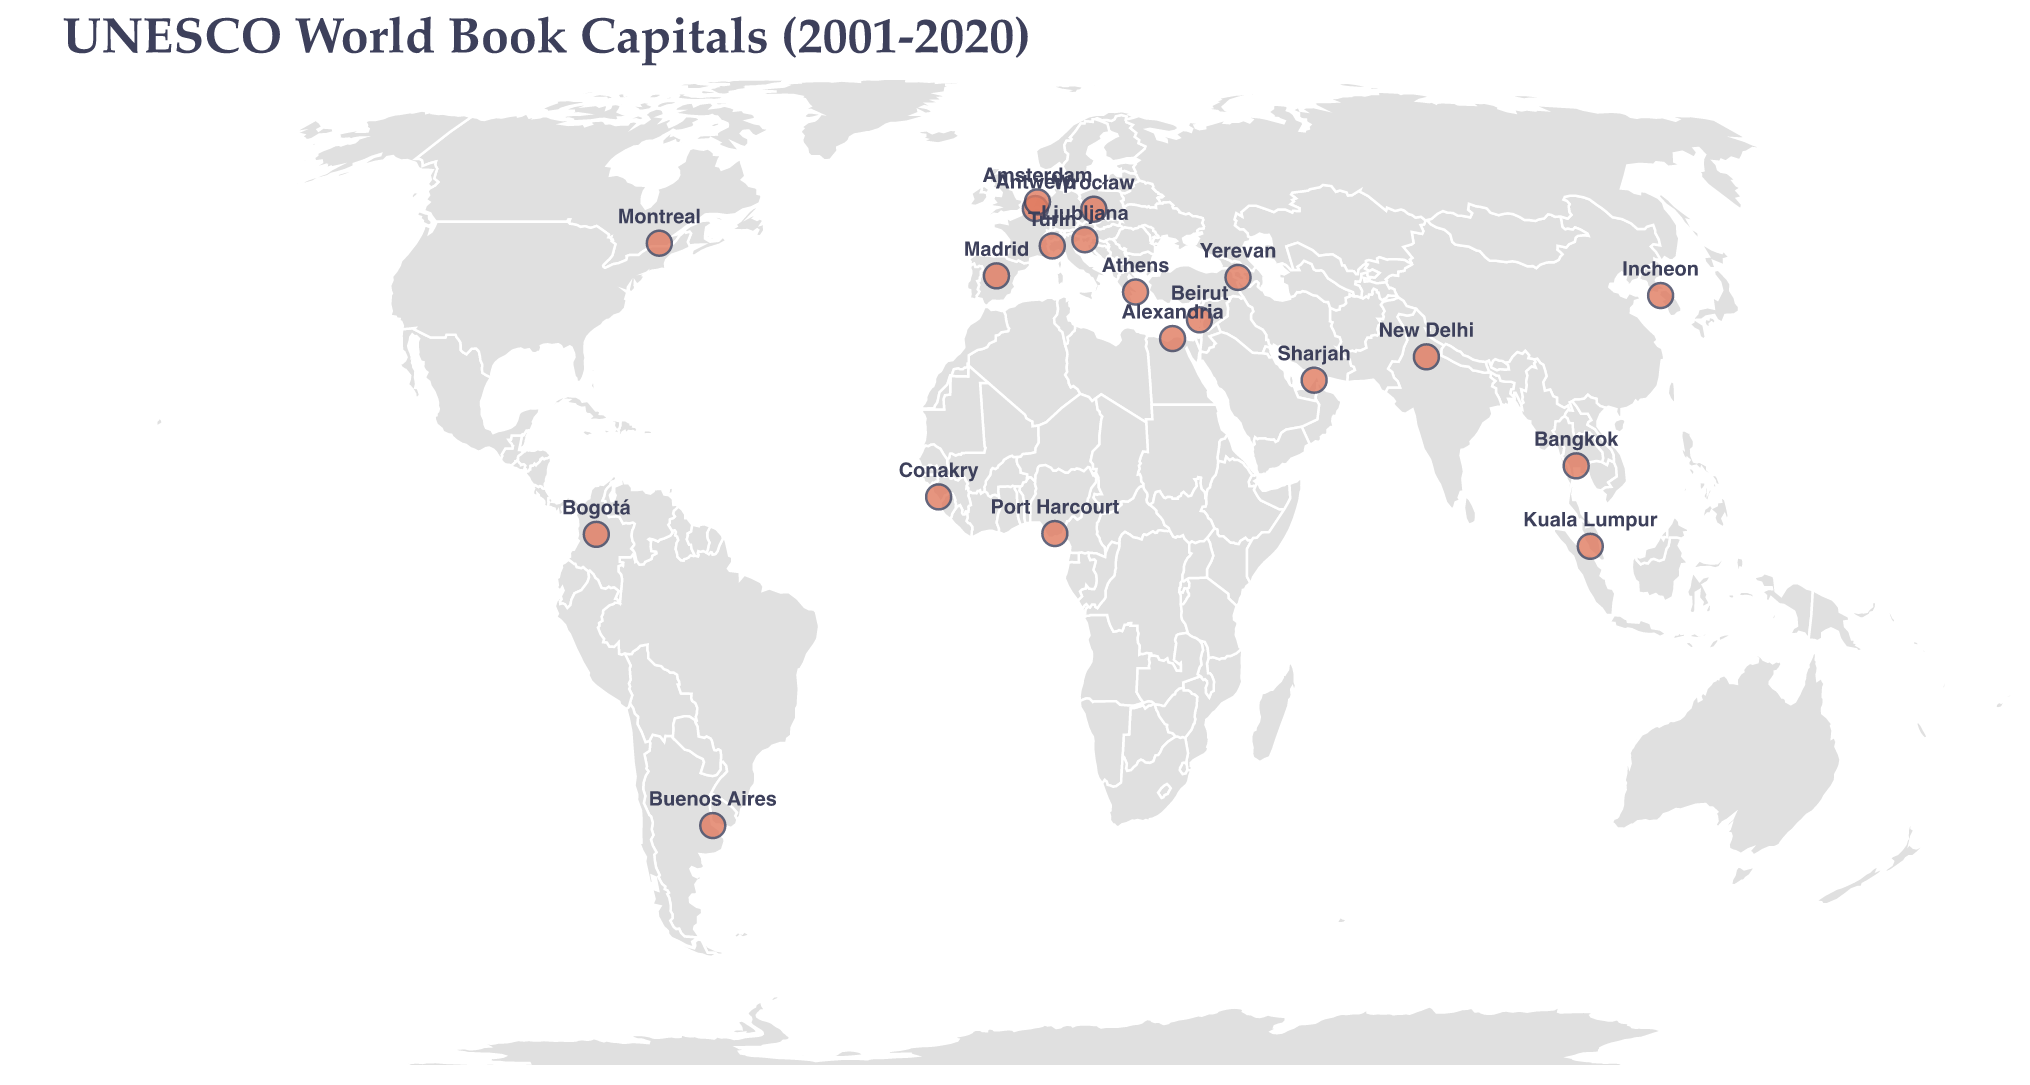Which city was the UNESCO World Book Capital in 2001? The figure lists Madrid, Spain, with the corresponding year 2001. The city's name is displayed above its location on the map.
Answer: Madrid In which year was Kuala Lumpur designated as the UNESCO World Book Capital? The figure shows Kuala Lumpur, Malaysia marked with the year 2020 next to its location on the map.
Answer: 2020 How many times has a city in South America been chosen as the UNESCO World Book Capital? The figure shows Bogotá, Colombia (2007) and Buenos Aires, Argentina (2011) marked on the map, indicating two South American cities.
Answer: 2 What are the latitudes and longitudes of the UNESCO World Book Capitals in Africa? The figure shows Port Harcourt, Nigeria (latitude 4.8156, longitude 7.0498) and Conakry, Guinea (latitude 9.6412, longitude -13.5784) as the African capitals marked on the map.
Answer: Port Harcourt: 4.8156, 7.0498; Conakry: 9.6412, -13.5784 How does the geographic distribution of UNESCO World Book Capitals differ between Europe and Asia? In Europe, the figure marks cities such as Madrid, Antwerp, Turin, Ljubljana, Wrocław, and Athens. In Asia, it shows New Delhi, Bangkok, Incheon, Sharjah, and Kuala Lumpur. The distribution appears more concentrated in Europe compared to the wider geographical spread in Asia.
Answer: Europe has more concentrated distribution Which city had the UNESCO World Book Capital title right before Buenos Aires? The figure shows Ljubljana, Slovenia as the UNESCO World Book Capital in 2010, whereas Buenos Aires, Argentina had the title in 2011, indicating Ljubljana is right before Buenos Aires.
Answer: Ljubljana Which continents have hosted fewer than 3 UNESCO World Book Capitals according to the map? Based on the map, Africa and Oceania have fewer than 3 UNESCO World Book Capitals, with Africa having Port Harcourt and Conakry, and none in Oceania.
Answer: Africa, Oceania What is the average longitude of the UNESCO World Book Capitals located in Asia? Capitals in Asia are New Delhi (77.2090), Bangkok (100.5018), Sharjah (55.4033), Incheon (126.7052), and Kuala Lumpur (101.6869). Summing these longitudes and dividing by 5: (77.2090 + 100.5018 + 55.4033 + 126.7052 + 101.6869) / 5 ≈ 92.7012.
Answer: 92.7 Which city is located furthest south among the UNESCO World Book Capitals? The map indicates Buenos Aires, Argentina (latitude -34.6037) as the southernmost city.
Answer: Buenos Aires 